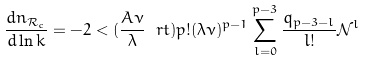Convert formula to latex. <formula><loc_0><loc_0><loc_500><loc_500>\frac { d n _ { \mathcal { R } _ { c } } } { d \ln k } = - 2 < ( \frac { A \nu } { \lambda } \ r t ) p ! ( \lambda \nu ) ^ { p - 1 } \sum _ { l = 0 } ^ { p - 3 } \frac { q _ { p - 3 - l } } { l ! } \mathcal { N } ^ { l }</formula> 